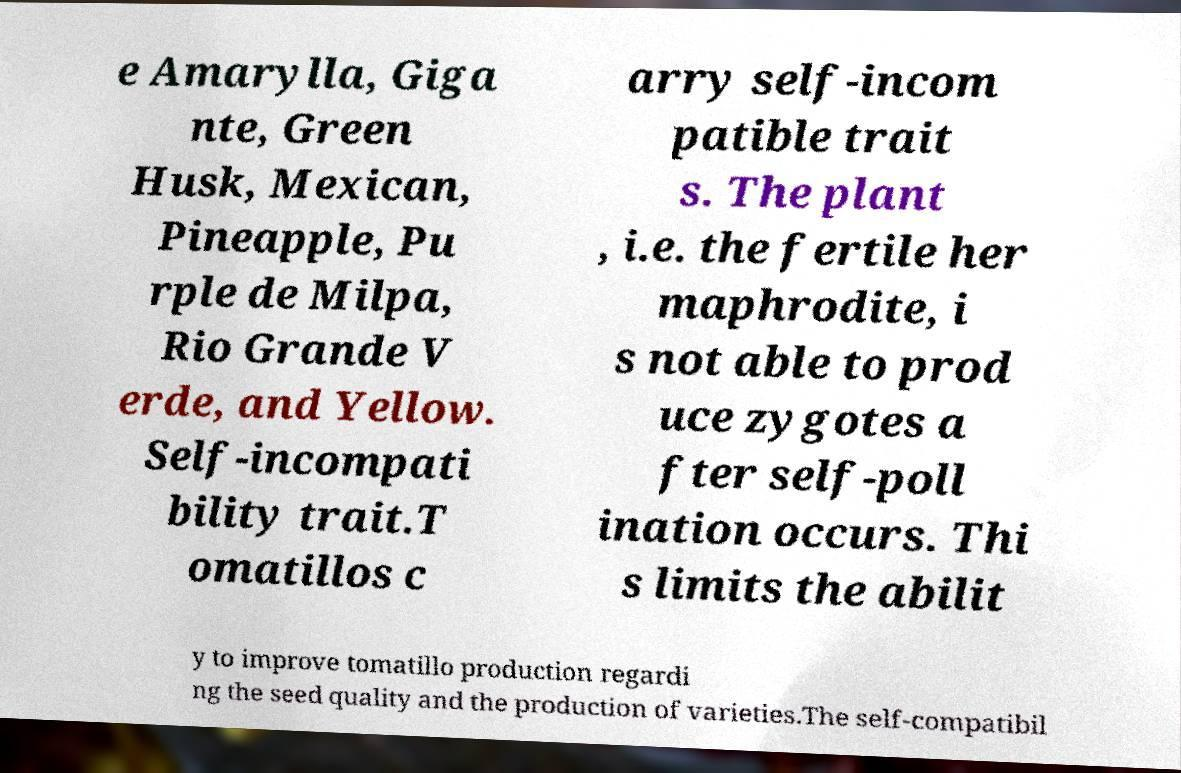Could you assist in decoding the text presented in this image and type it out clearly? e Amarylla, Giga nte, Green Husk, Mexican, Pineapple, Pu rple de Milpa, Rio Grande V erde, and Yellow. Self-incompati bility trait.T omatillos c arry self-incom patible trait s. The plant , i.e. the fertile her maphrodite, i s not able to prod uce zygotes a fter self-poll ination occurs. Thi s limits the abilit y to improve tomatillo production regardi ng the seed quality and the production of varieties.The self-compatibil 